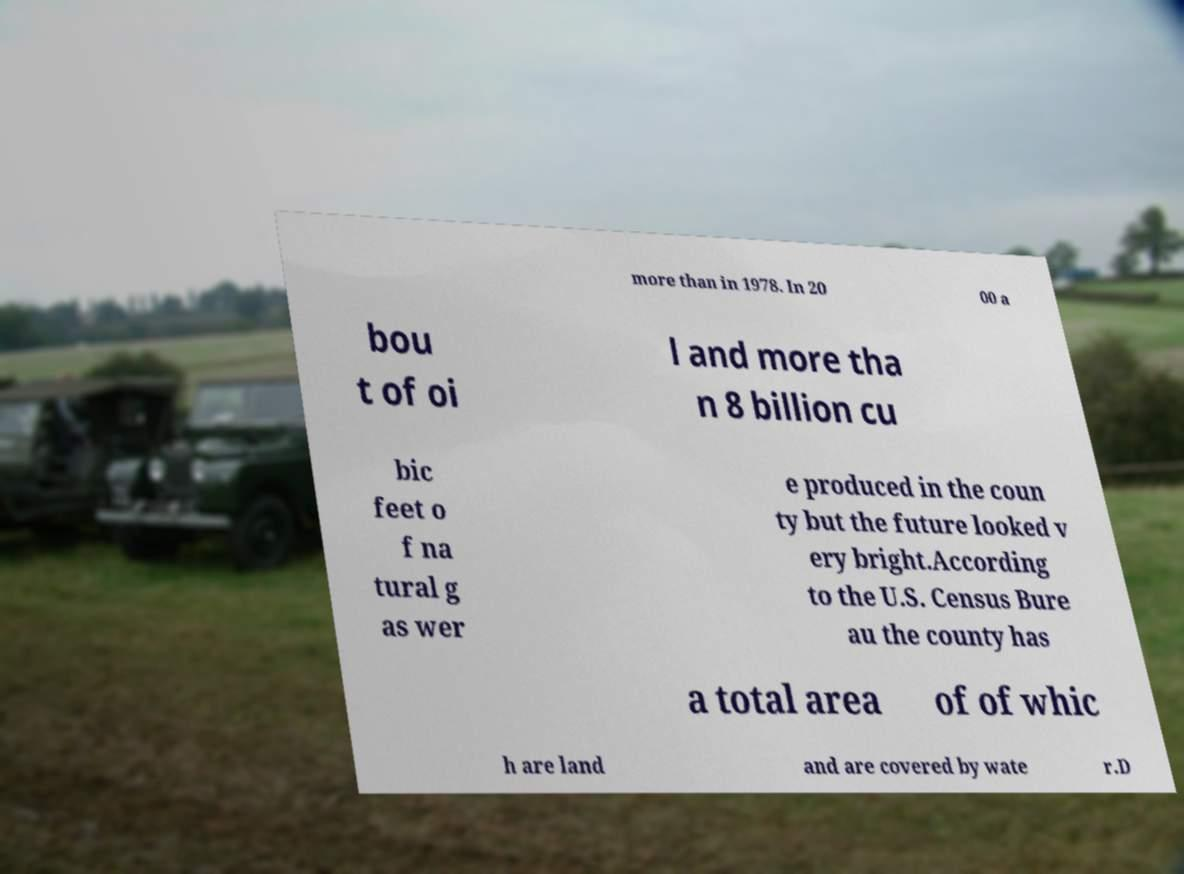Please identify and transcribe the text found in this image. more than in 1978. In 20 00 a bou t of oi l and more tha n 8 billion cu bic feet o f na tural g as wer e produced in the coun ty but the future looked v ery bright.According to the U.S. Census Bure au the county has a total area of of whic h are land and are covered by wate r.D 